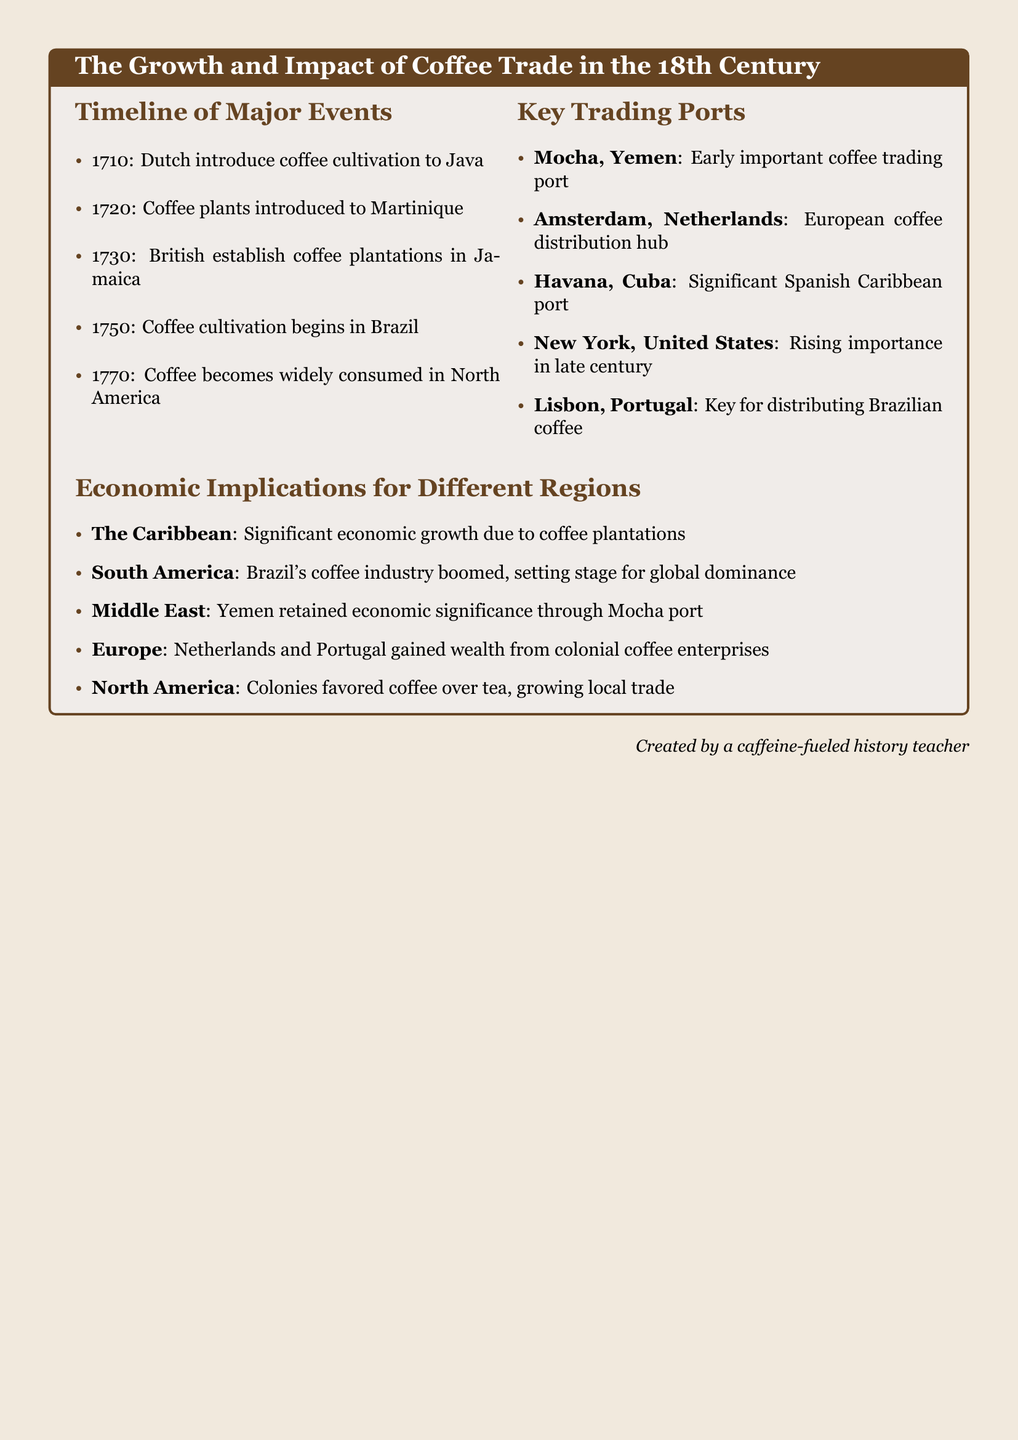what year were coffee plants introduced to Martinique? The document states that coffee plants were introduced to Martinique in the year 1720.
Answer: 1720 which port was an early important coffee trading port? The document lists Mocha, Yemen as an early important coffee trading port.
Answer: Mocha, Yemen what economic impact did coffee plantations have in the Caribbean? It mentions that the Caribbean experienced significant economic growth due to coffee plantations.
Answer: Economic growth when did coffee cultivation begin in Brazil? According to the document, coffee cultivation in Brazil began in the year 1750.
Answer: 1750 which European country gained wealth from colonial coffee enterprises? The document indicates that both the Netherlands and Portugal gained wealth from their colonial coffee enterprises.
Answer: Netherlands and Portugal what was the key reason North American colonies favored coffee over tea? The document implies that coffee became widely consumed in North America in 1770, favoring local trade.
Answer: Widely consumed which significant port in the United States rose in importance towards the late century? The document notes New York, United States as a rising important port in the late century.
Answer: New York, United States how many major events are listed in the timeline? The document lists five major events in the timeline of coffee trade.
Answer: Five what is the primary focus of this datasheet? The document primarily focuses on the growth and impact of coffee trade in the 18th century.
Answer: Coffee trade in the 18th century 